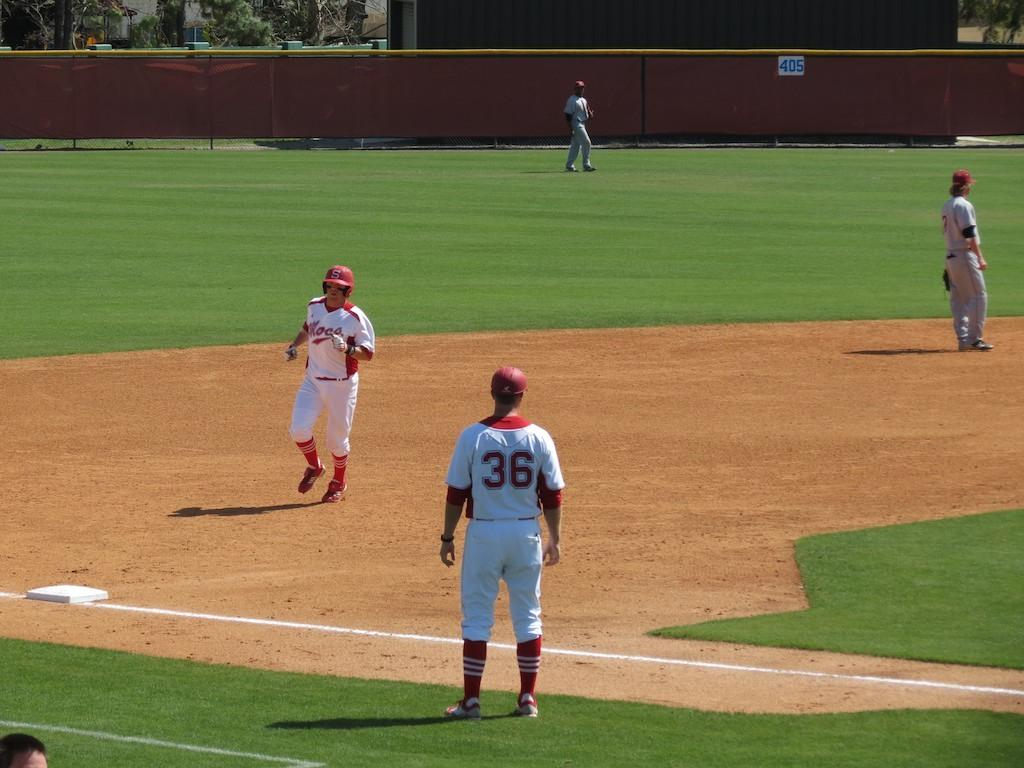<image>
Summarize the visual content of the image. Baseball players on a field one of the players have 36 on their jersey. 